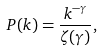Convert formula to latex. <formula><loc_0><loc_0><loc_500><loc_500>P ( k ) = \frac { k ^ { - \gamma } } { \zeta ( \gamma ) } ,</formula> 